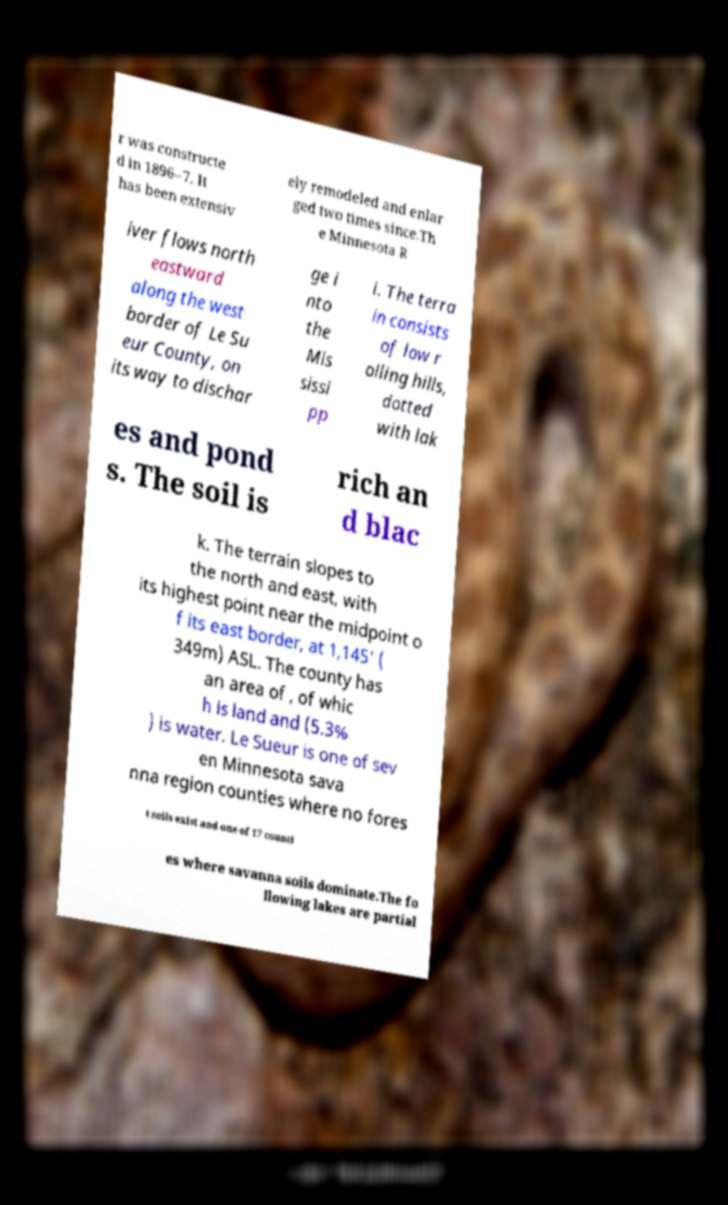Please read and relay the text visible in this image. What does it say? r was constructe d in 1896–7. It has been extensiv ely remodeled and enlar ged two times since.Th e Minnesota R iver flows north eastward along the west border of Le Su eur County, on its way to dischar ge i nto the Mis sissi pp i. The terra in consists of low r olling hills, dotted with lak es and pond s. The soil is rich an d blac k. The terrain slopes to the north and east, with its highest point near the midpoint o f its east border, at 1,145' ( 349m) ASL. The county has an area of , of whic h is land and (5.3% ) is water. Le Sueur is one of sev en Minnesota sava nna region counties where no fores t soils exist and one of 17 counti es where savanna soils dominate.The fo llowing lakes are partial 